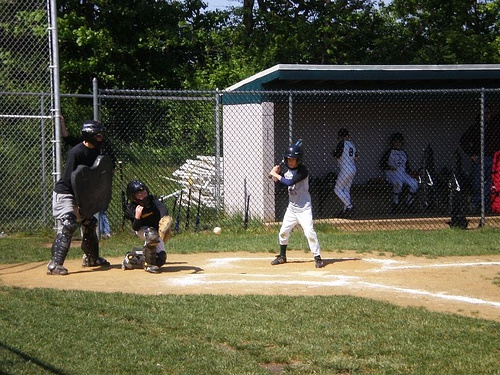Describe the objects in this image and their specific colors. I can see people in gray, black, lightgray, and darkgray tones, people in gray, black, and maroon tones, people in gray, white, black, and darkgray tones, people in gray, black, and maroon tones, and people in gray, black, navy, and darkblue tones in this image. 